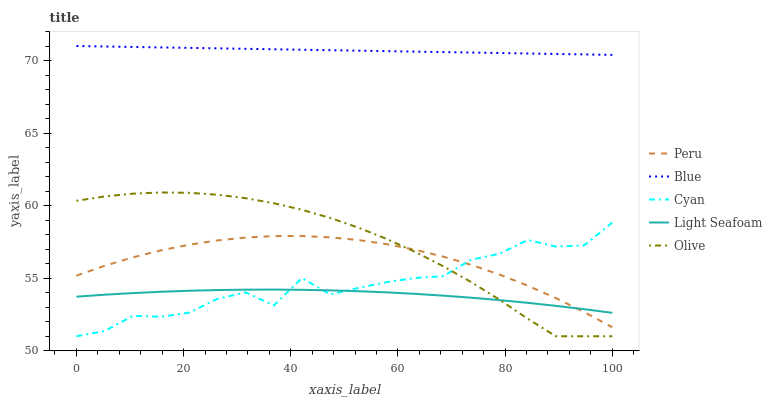Does Cyan have the minimum area under the curve?
Answer yes or no. No. Does Cyan have the maximum area under the curve?
Answer yes or no. No. Is Light Seafoam the smoothest?
Answer yes or no. No. Is Light Seafoam the roughest?
Answer yes or no. No. Does Light Seafoam have the lowest value?
Answer yes or no. No. Does Cyan have the highest value?
Answer yes or no. No. Is Olive less than Blue?
Answer yes or no. Yes. Is Blue greater than Peru?
Answer yes or no. Yes. Does Olive intersect Blue?
Answer yes or no. No. 